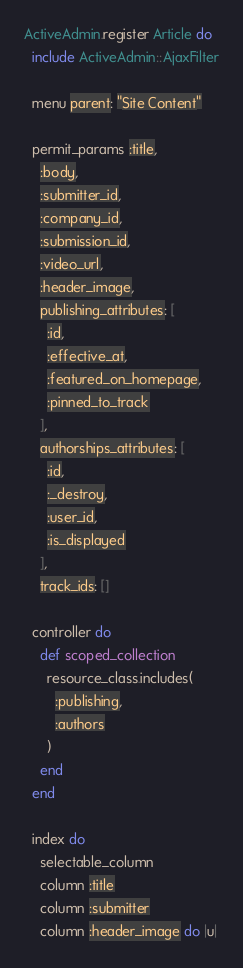<code> <loc_0><loc_0><loc_500><loc_500><_Ruby_>ActiveAdmin.register Article do
  include ActiveAdmin::AjaxFilter

  menu parent: "Site Content"

  permit_params :title,
    :body,
    :submitter_id,
    :company_id,
    :submission_id,
    :video_url,
    :header_image,
    publishing_attributes: [
      :id,
      :effective_at,
      :featured_on_homepage,
      :pinned_to_track
    ],
    authorships_attributes: [
      :id,
      :_destroy,
      :user_id,
      :is_displayed
    ],
    track_ids: []

  controller do
    def scoped_collection
      resource_class.includes(
        :publishing,
        :authors
      )
    end
  end

  index do
    selectable_column
    column :title
    column :submitter
    column :header_image do |u|</code> 